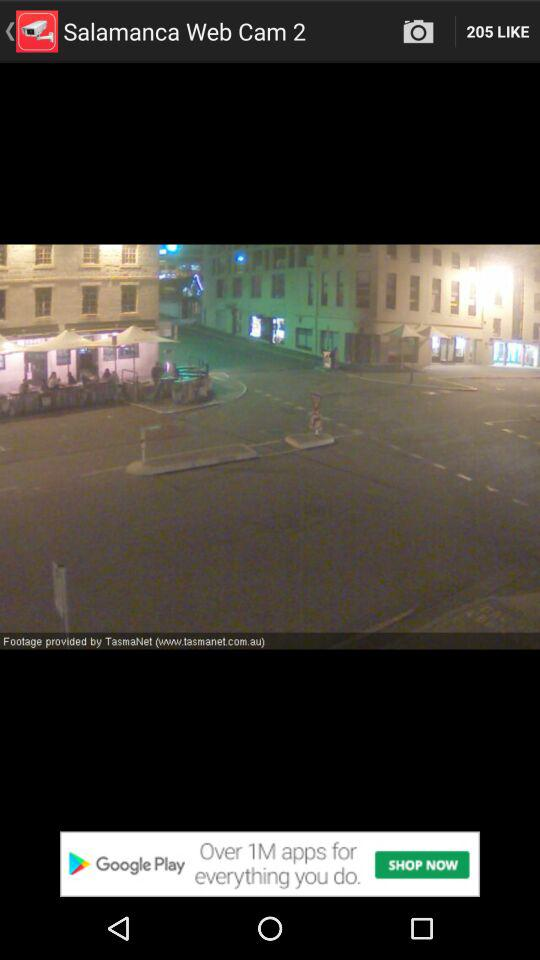How many likes are shown? There are 205 likes shown. 